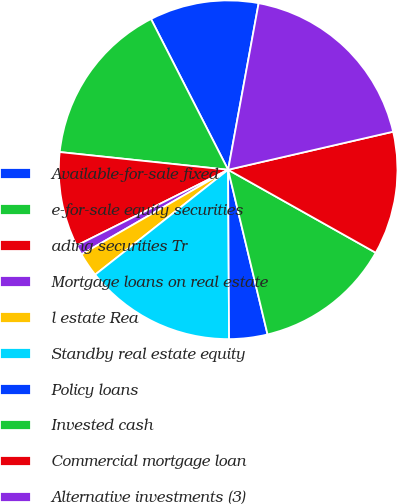Convert chart to OTSL. <chart><loc_0><loc_0><loc_500><loc_500><pie_chart><fcel>Available-for-sale fixed<fcel>e-for-sale equity securities<fcel>ading securities Tr<fcel>Mortgage loans on real estate<fcel>l estate Rea<fcel>Standby real estate equity<fcel>Policy loans<fcel>Invested cash<fcel>Commercial mortgage loan<fcel>Alternative investments (3)<nl><fcel>10.41%<fcel>15.81%<fcel>9.05%<fcel>0.95%<fcel>2.3%<fcel>14.46%<fcel>3.65%<fcel>13.11%<fcel>11.76%<fcel>18.51%<nl></chart> 